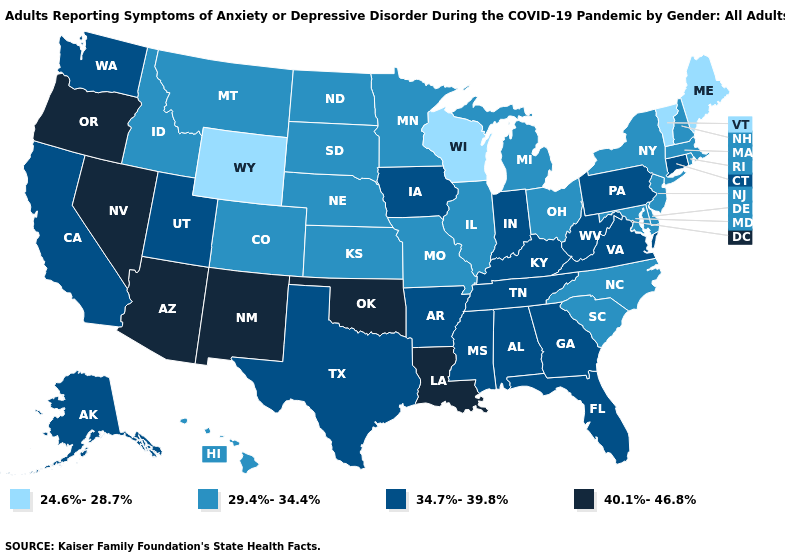How many symbols are there in the legend?
Keep it brief. 4. What is the value of Florida?
Keep it brief. 34.7%-39.8%. Name the states that have a value in the range 24.6%-28.7%?
Be succinct. Maine, Vermont, Wisconsin, Wyoming. Does Hawaii have the highest value in the USA?
Short answer required. No. What is the lowest value in the USA?
Write a very short answer. 24.6%-28.7%. What is the value of Arkansas?
Concise answer only. 34.7%-39.8%. Does the first symbol in the legend represent the smallest category?
Concise answer only. Yes. How many symbols are there in the legend?
Write a very short answer. 4. Name the states that have a value in the range 40.1%-46.8%?
Answer briefly. Arizona, Louisiana, Nevada, New Mexico, Oklahoma, Oregon. What is the highest value in the Northeast ?
Give a very brief answer. 34.7%-39.8%. Which states have the lowest value in the South?
Keep it brief. Delaware, Maryland, North Carolina, South Carolina. Name the states that have a value in the range 29.4%-34.4%?
Short answer required. Colorado, Delaware, Hawaii, Idaho, Illinois, Kansas, Maryland, Massachusetts, Michigan, Minnesota, Missouri, Montana, Nebraska, New Hampshire, New Jersey, New York, North Carolina, North Dakota, Ohio, Rhode Island, South Carolina, South Dakota. Name the states that have a value in the range 29.4%-34.4%?
Give a very brief answer. Colorado, Delaware, Hawaii, Idaho, Illinois, Kansas, Maryland, Massachusetts, Michigan, Minnesota, Missouri, Montana, Nebraska, New Hampshire, New Jersey, New York, North Carolina, North Dakota, Ohio, Rhode Island, South Carolina, South Dakota. What is the value of Colorado?
Answer briefly. 29.4%-34.4%. Name the states that have a value in the range 24.6%-28.7%?
Concise answer only. Maine, Vermont, Wisconsin, Wyoming. 